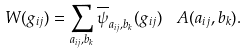<formula> <loc_0><loc_0><loc_500><loc_500>W ( g _ { i j } ) = \sum _ { a _ { i j } , b _ { k } } \overline { \psi } _ { a _ { i j } , b _ { k } } ( g _ { i j } ) \ \ A ( a _ { i j } , b _ { k } ) .</formula> 